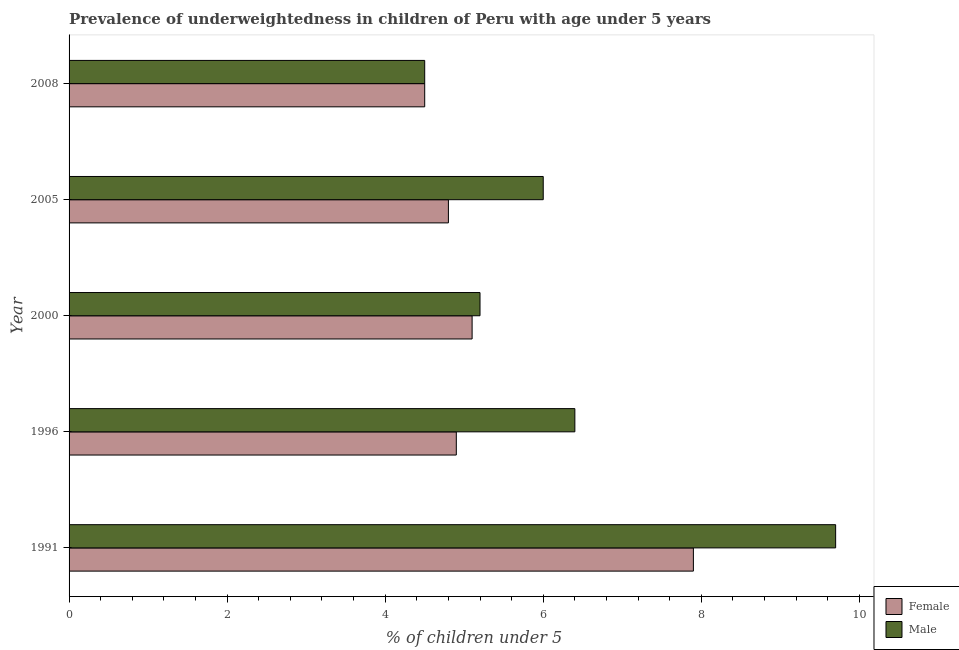How many different coloured bars are there?
Give a very brief answer. 2. How many groups of bars are there?
Provide a succinct answer. 5. What is the label of the 2nd group of bars from the top?
Your answer should be very brief. 2005. What is the percentage of underweighted male children in 2005?
Offer a terse response. 6. Across all years, what is the maximum percentage of underweighted female children?
Offer a terse response. 7.9. Across all years, what is the minimum percentage of underweighted male children?
Make the answer very short. 4.5. What is the total percentage of underweighted male children in the graph?
Provide a short and direct response. 31.8. What is the difference between the percentage of underweighted female children in 2000 and the percentage of underweighted male children in 2005?
Keep it short and to the point. -0.9. What is the average percentage of underweighted female children per year?
Ensure brevity in your answer.  5.44. In how many years, is the percentage of underweighted male children greater than 9.2 %?
Ensure brevity in your answer.  1. What is the ratio of the percentage of underweighted male children in 1991 to that in 2005?
Keep it short and to the point. 1.62. Is the percentage of underweighted female children in 1996 less than that in 2000?
Offer a terse response. Yes. What is the difference between the highest and the second highest percentage of underweighted female children?
Give a very brief answer. 2.8. In how many years, is the percentage of underweighted male children greater than the average percentage of underweighted male children taken over all years?
Your answer should be compact. 2. Is the sum of the percentage of underweighted female children in 1996 and 2000 greater than the maximum percentage of underweighted male children across all years?
Keep it short and to the point. Yes. What does the 2nd bar from the bottom in 2005 represents?
Keep it short and to the point. Male. How many bars are there?
Your answer should be very brief. 10. How many years are there in the graph?
Provide a short and direct response. 5. Does the graph contain any zero values?
Provide a short and direct response. No. Does the graph contain grids?
Ensure brevity in your answer.  No. How many legend labels are there?
Offer a very short reply. 2. How are the legend labels stacked?
Give a very brief answer. Vertical. What is the title of the graph?
Your response must be concise. Prevalence of underweightedness in children of Peru with age under 5 years. What is the label or title of the X-axis?
Offer a terse response.  % of children under 5. What is the label or title of the Y-axis?
Give a very brief answer. Year. What is the  % of children under 5 of Female in 1991?
Offer a very short reply. 7.9. What is the  % of children under 5 in Male in 1991?
Keep it short and to the point. 9.7. What is the  % of children under 5 of Female in 1996?
Offer a terse response. 4.9. What is the  % of children under 5 of Male in 1996?
Keep it short and to the point. 6.4. What is the  % of children under 5 of Female in 2000?
Keep it short and to the point. 5.1. What is the  % of children under 5 of Male in 2000?
Your response must be concise. 5.2. What is the  % of children under 5 in Female in 2005?
Provide a short and direct response. 4.8. What is the  % of children under 5 of Male in 2005?
Provide a succinct answer. 6. What is the  % of children under 5 of Female in 2008?
Your response must be concise. 4.5. Across all years, what is the maximum  % of children under 5 in Female?
Your answer should be compact. 7.9. Across all years, what is the maximum  % of children under 5 in Male?
Make the answer very short. 9.7. Across all years, what is the minimum  % of children under 5 of Female?
Offer a very short reply. 4.5. What is the total  % of children under 5 in Female in the graph?
Your answer should be very brief. 27.2. What is the total  % of children under 5 in Male in the graph?
Keep it short and to the point. 31.8. What is the difference between the  % of children under 5 of Female in 1991 and that in 1996?
Offer a very short reply. 3. What is the difference between the  % of children under 5 in Female in 1991 and that in 2008?
Your answer should be very brief. 3.4. What is the difference between the  % of children under 5 in Female in 1996 and that in 2005?
Ensure brevity in your answer.  0.1. What is the difference between the  % of children under 5 in Male in 1996 and that in 2005?
Keep it short and to the point. 0.4. What is the difference between the  % of children under 5 of Female in 1996 and that in 2008?
Your answer should be very brief. 0.4. What is the difference between the  % of children under 5 of Male in 1996 and that in 2008?
Offer a very short reply. 1.9. What is the difference between the  % of children under 5 in Male in 2000 and that in 2005?
Your answer should be compact. -0.8. What is the difference between the  % of children under 5 in Male in 2000 and that in 2008?
Your response must be concise. 0.7. What is the difference between the  % of children under 5 of Female in 2005 and that in 2008?
Your answer should be compact. 0.3. What is the difference between the  % of children under 5 in Male in 2005 and that in 2008?
Make the answer very short. 1.5. What is the difference between the  % of children under 5 of Female in 1991 and the  % of children under 5 of Male in 1996?
Provide a succinct answer. 1.5. What is the difference between the  % of children under 5 of Female in 1996 and the  % of children under 5 of Male in 2000?
Offer a terse response. -0.3. What is the difference between the  % of children under 5 in Female in 2000 and the  % of children under 5 in Male in 2005?
Provide a short and direct response. -0.9. What is the average  % of children under 5 in Female per year?
Ensure brevity in your answer.  5.44. What is the average  % of children under 5 of Male per year?
Ensure brevity in your answer.  6.36. In the year 2008, what is the difference between the  % of children under 5 of Female and  % of children under 5 of Male?
Your answer should be compact. 0. What is the ratio of the  % of children under 5 in Female in 1991 to that in 1996?
Provide a succinct answer. 1.61. What is the ratio of the  % of children under 5 in Male in 1991 to that in 1996?
Provide a succinct answer. 1.52. What is the ratio of the  % of children under 5 in Female in 1991 to that in 2000?
Keep it short and to the point. 1.55. What is the ratio of the  % of children under 5 of Male in 1991 to that in 2000?
Offer a terse response. 1.87. What is the ratio of the  % of children under 5 of Female in 1991 to that in 2005?
Make the answer very short. 1.65. What is the ratio of the  % of children under 5 in Male in 1991 to that in 2005?
Provide a short and direct response. 1.62. What is the ratio of the  % of children under 5 in Female in 1991 to that in 2008?
Provide a succinct answer. 1.76. What is the ratio of the  % of children under 5 of Male in 1991 to that in 2008?
Provide a succinct answer. 2.16. What is the ratio of the  % of children under 5 in Female in 1996 to that in 2000?
Make the answer very short. 0.96. What is the ratio of the  % of children under 5 of Male in 1996 to that in 2000?
Offer a terse response. 1.23. What is the ratio of the  % of children under 5 in Female in 1996 to that in 2005?
Ensure brevity in your answer.  1.02. What is the ratio of the  % of children under 5 in Male in 1996 to that in 2005?
Your answer should be compact. 1.07. What is the ratio of the  % of children under 5 in Female in 1996 to that in 2008?
Your answer should be very brief. 1.09. What is the ratio of the  % of children under 5 of Male in 1996 to that in 2008?
Keep it short and to the point. 1.42. What is the ratio of the  % of children under 5 in Female in 2000 to that in 2005?
Provide a succinct answer. 1.06. What is the ratio of the  % of children under 5 in Male in 2000 to that in 2005?
Offer a very short reply. 0.87. What is the ratio of the  % of children under 5 of Female in 2000 to that in 2008?
Provide a succinct answer. 1.13. What is the ratio of the  % of children under 5 of Male in 2000 to that in 2008?
Give a very brief answer. 1.16. What is the ratio of the  % of children under 5 of Female in 2005 to that in 2008?
Ensure brevity in your answer.  1.07. What is the difference between the highest and the second highest  % of children under 5 of Female?
Your answer should be compact. 2.8. What is the difference between the highest and the second highest  % of children under 5 of Male?
Give a very brief answer. 3.3. What is the difference between the highest and the lowest  % of children under 5 of Female?
Ensure brevity in your answer.  3.4. What is the difference between the highest and the lowest  % of children under 5 of Male?
Your response must be concise. 5.2. 